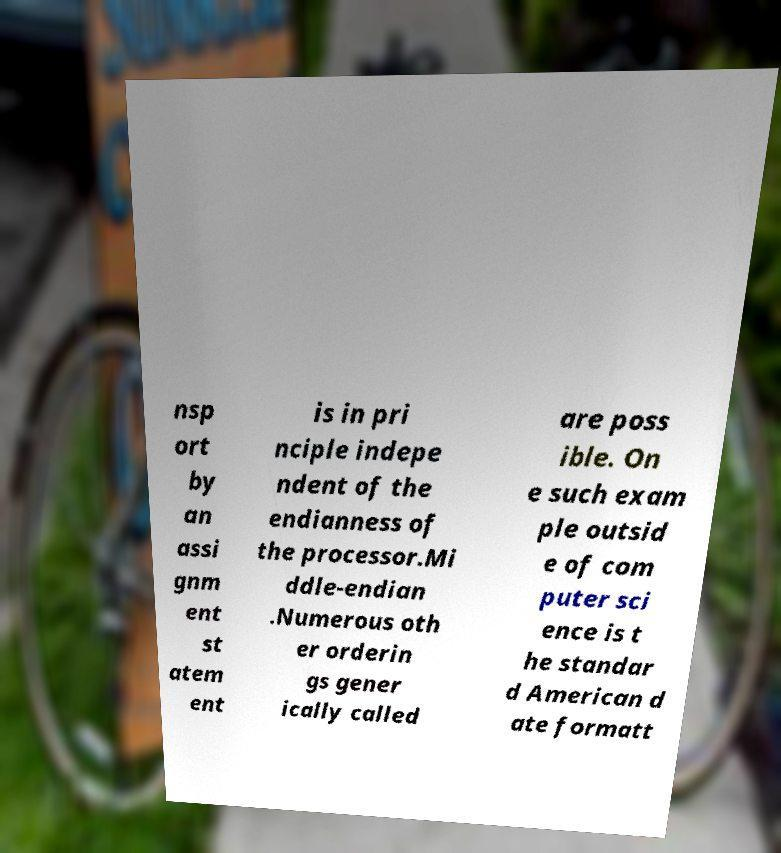For documentation purposes, I need the text within this image transcribed. Could you provide that? nsp ort by an assi gnm ent st atem ent is in pri nciple indepe ndent of the endianness of the processor.Mi ddle-endian .Numerous oth er orderin gs gener ically called are poss ible. On e such exam ple outsid e of com puter sci ence is t he standar d American d ate formatt 